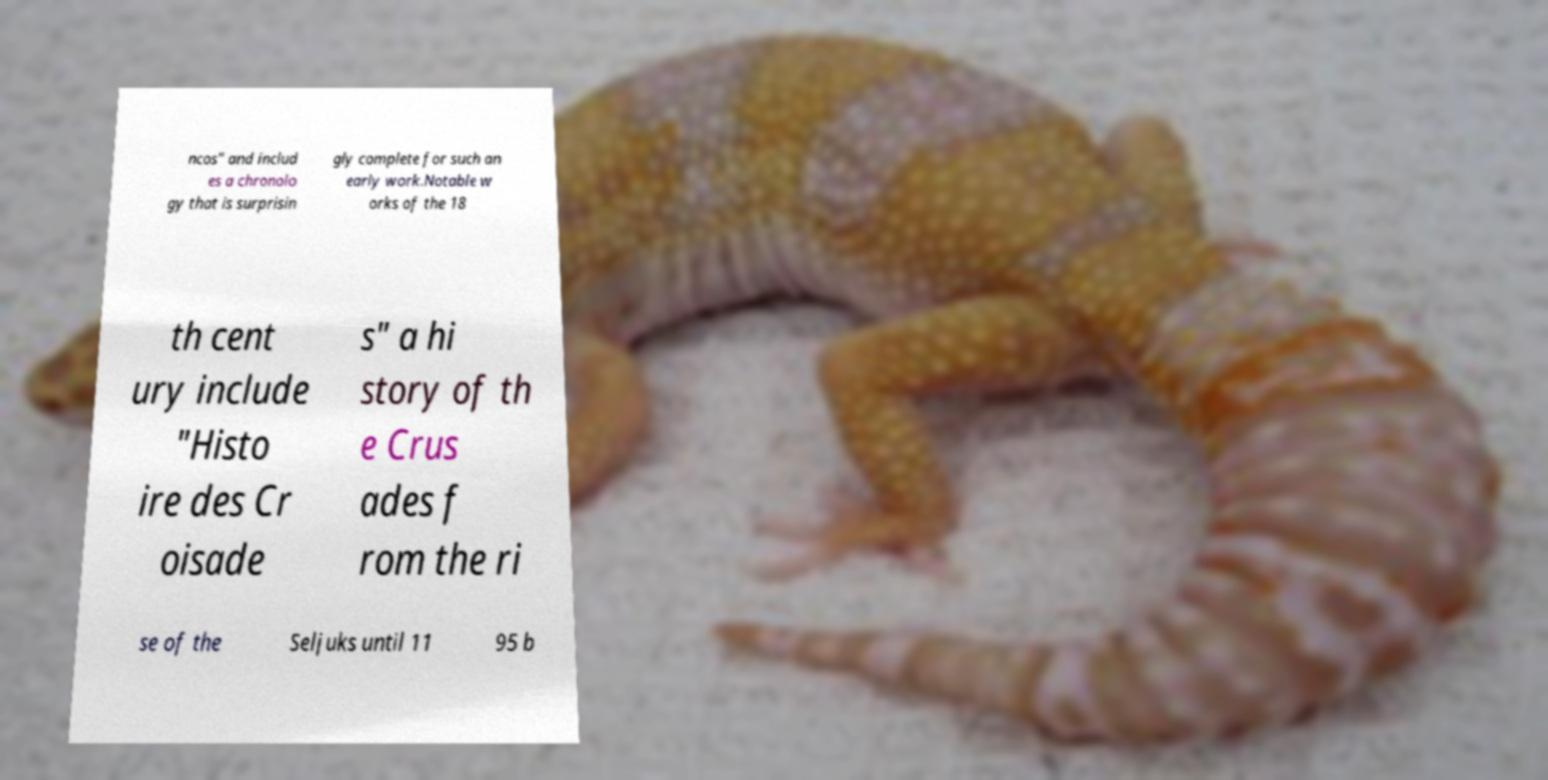Please read and relay the text visible in this image. What does it say? ncos" and includ es a chronolo gy that is surprisin gly complete for such an early work.Notable w orks of the 18 th cent ury include "Histo ire des Cr oisade s" a hi story of th e Crus ades f rom the ri se of the Seljuks until 11 95 b 